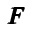<formula> <loc_0><loc_0><loc_500><loc_500>{ \pm b F }</formula> 